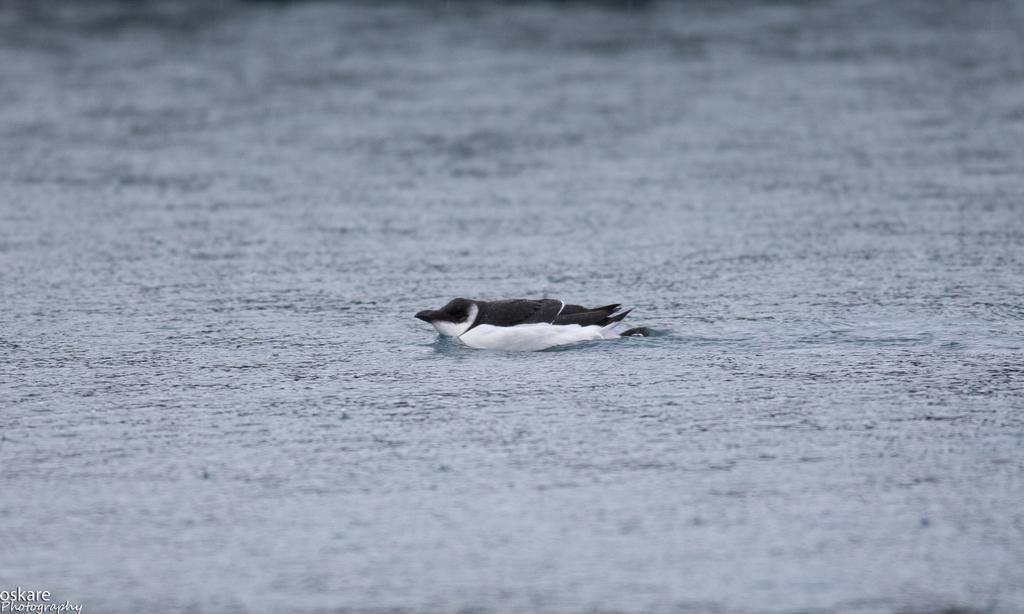What animal is present in the image? There is a duck in the image. What colors can be seen on the duck? The duck is black and white in color. Where is the duck located in the image? The duck is in the river water. Is there any text present in the image? Yes, there is a small quote on the bottom left side of the image. How many children are wearing scarves in the image? There are no children or scarves present in the image; it features a black and white duck in the river water. 